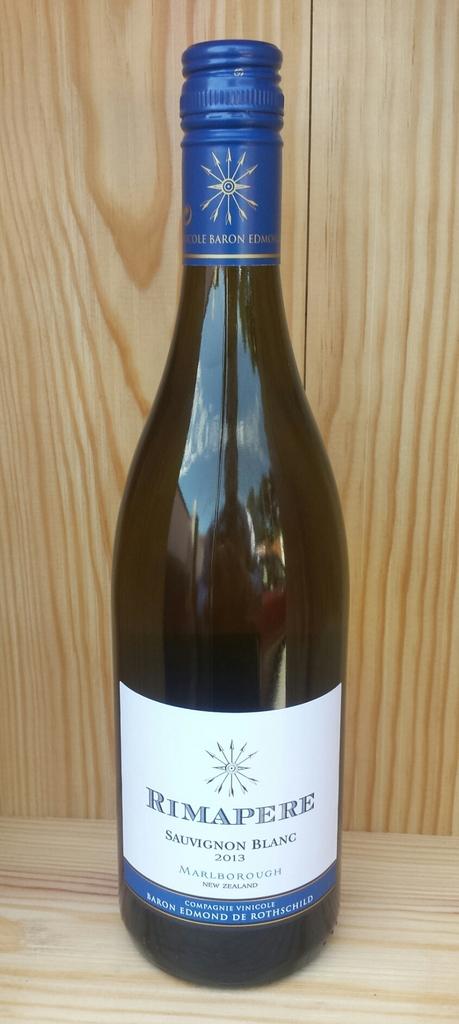What is the name of this sauvignon?
Offer a terse response. Rimapere. 